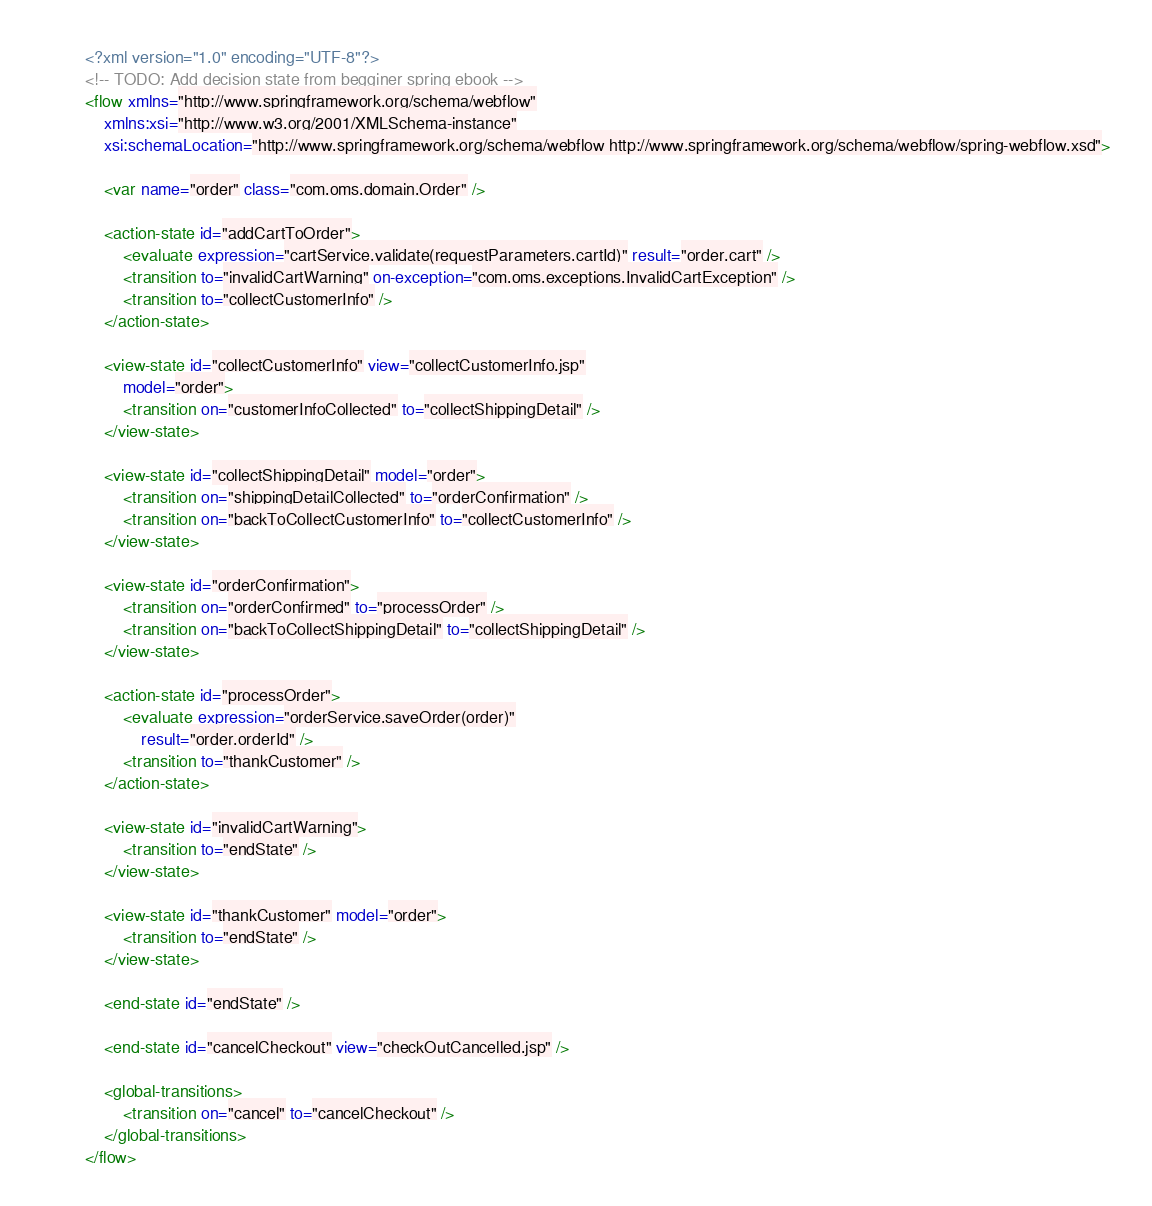Convert code to text. <code><loc_0><loc_0><loc_500><loc_500><_XML_><?xml version="1.0" encoding="UTF-8"?>
<!-- TODO: Add decision state from begginer spring ebook -->
<flow xmlns="http://www.springframework.org/schema/webflow"
	xmlns:xsi="http://www.w3.org/2001/XMLSchema-instance"
	xsi:schemaLocation="http://www.springframework.org/schema/webflow http://www.springframework.org/schema/webflow/spring-webflow.xsd">

	<var name="order" class="com.oms.domain.Order" />

	<action-state id="addCartToOrder">
		<evaluate expression="cartService.validate(requestParameters.cartId)" result="order.cart" />
		<transition to="invalidCartWarning" on-exception="com.oms.exceptions.InvalidCartException" />
		<transition to="collectCustomerInfo" />
	</action-state>

	<view-state id="collectCustomerInfo" view="collectCustomerInfo.jsp"
		model="order">
		<transition on="customerInfoCollected" to="collectShippingDetail" />
	</view-state>

	<view-state id="collectShippingDetail" model="order">
		<transition on="shippingDetailCollected" to="orderConfirmation" />
		<transition on="backToCollectCustomerInfo" to="collectCustomerInfo" />
	</view-state>

	<view-state id="orderConfirmation">
		<transition on="orderConfirmed" to="processOrder" />
		<transition on="backToCollectShippingDetail" to="collectShippingDetail" />
	</view-state>

	<action-state id="processOrder">
		<evaluate expression="orderService.saveOrder(order)"
			result="order.orderId" />
		<transition to="thankCustomer" />
	</action-state>

	<view-state id="invalidCartWarning">
		<transition to="endState" />
	</view-state>

	<view-state id="thankCustomer" model="order">
		<transition to="endState" />
	</view-state>

	<end-state id="endState" />

	<end-state id="cancelCheckout" view="checkOutCancelled.jsp" />

	<global-transitions>
		<transition on="cancel" to="cancelCheckout" />
	</global-transitions>
</flow> </code> 